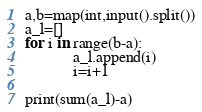Convert code to text. <code><loc_0><loc_0><loc_500><loc_500><_Python_>a,b=map(int,input().split())
a_l=[]
for i in range(b-a):
            a_l.append(i)
            i=i+1

print(sum(a_l)-a)

</code> 